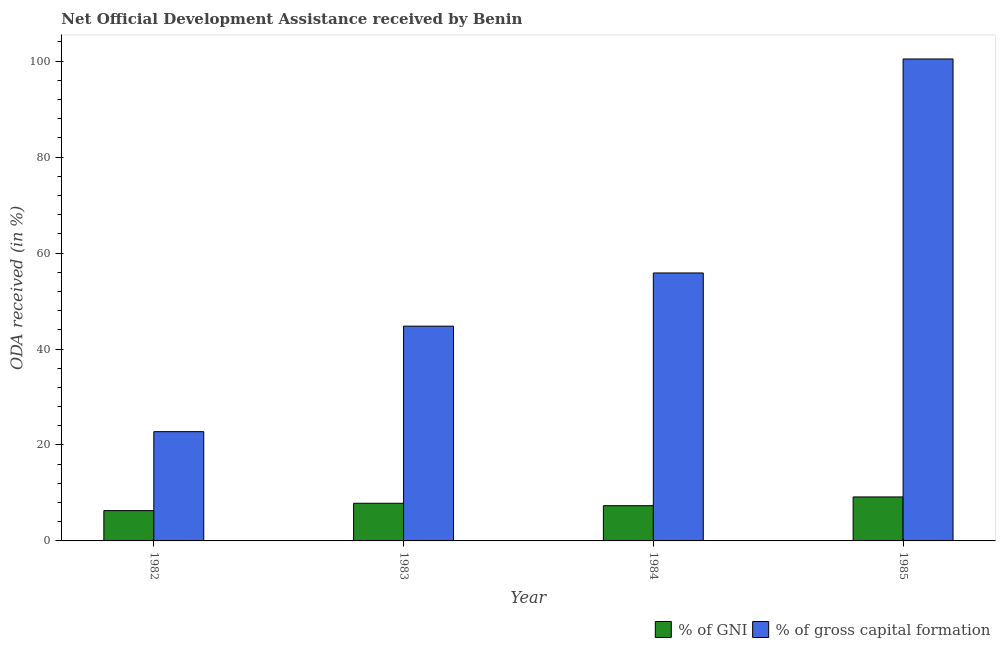Are the number of bars per tick equal to the number of legend labels?
Provide a succinct answer. Yes. Are the number of bars on each tick of the X-axis equal?
Keep it short and to the point. Yes. How many bars are there on the 3rd tick from the left?
Your response must be concise. 2. How many bars are there on the 1st tick from the right?
Give a very brief answer. 2. What is the label of the 4th group of bars from the left?
Provide a short and direct response. 1985. What is the oda received as percentage of gross capital formation in 1984?
Keep it short and to the point. 55.85. Across all years, what is the maximum oda received as percentage of gni?
Your answer should be very brief. 9.17. Across all years, what is the minimum oda received as percentage of gross capital formation?
Provide a short and direct response. 22.77. In which year was the oda received as percentage of gross capital formation maximum?
Keep it short and to the point. 1985. In which year was the oda received as percentage of gross capital formation minimum?
Your answer should be compact. 1982. What is the total oda received as percentage of gross capital formation in the graph?
Provide a short and direct response. 223.84. What is the difference between the oda received as percentage of gross capital formation in 1983 and that in 1985?
Offer a terse response. -55.69. What is the difference between the oda received as percentage of gross capital formation in 1985 and the oda received as percentage of gni in 1983?
Your response must be concise. 55.69. What is the average oda received as percentage of gross capital formation per year?
Offer a very short reply. 55.96. In how many years, is the oda received as percentage of gni greater than 88 %?
Give a very brief answer. 0. What is the ratio of the oda received as percentage of gni in 1982 to that in 1985?
Offer a very short reply. 0.69. Is the oda received as percentage of gni in 1983 less than that in 1984?
Provide a short and direct response. No. Is the difference between the oda received as percentage of gni in 1983 and 1985 greater than the difference between the oda received as percentage of gross capital formation in 1983 and 1985?
Your answer should be very brief. No. What is the difference between the highest and the second highest oda received as percentage of gross capital formation?
Make the answer very short. 44.6. What is the difference between the highest and the lowest oda received as percentage of gni?
Ensure brevity in your answer.  2.85. What does the 1st bar from the left in 1985 represents?
Give a very brief answer. % of GNI. What does the 2nd bar from the right in 1983 represents?
Offer a very short reply. % of GNI. Are all the bars in the graph horizontal?
Ensure brevity in your answer.  No. What is the difference between two consecutive major ticks on the Y-axis?
Your answer should be compact. 20. Are the values on the major ticks of Y-axis written in scientific E-notation?
Provide a succinct answer. No. Does the graph contain any zero values?
Provide a short and direct response. No. Where does the legend appear in the graph?
Offer a very short reply. Bottom right. How many legend labels are there?
Offer a terse response. 2. How are the legend labels stacked?
Make the answer very short. Horizontal. What is the title of the graph?
Your answer should be compact. Net Official Development Assistance received by Benin. What is the label or title of the Y-axis?
Your response must be concise. ODA received (in %). What is the ODA received (in %) in % of GNI in 1982?
Give a very brief answer. 6.32. What is the ODA received (in %) in % of gross capital formation in 1982?
Offer a terse response. 22.77. What is the ODA received (in %) in % of GNI in 1983?
Provide a short and direct response. 7.85. What is the ODA received (in %) in % of gross capital formation in 1983?
Your answer should be compact. 44.76. What is the ODA received (in %) in % of GNI in 1984?
Offer a terse response. 7.34. What is the ODA received (in %) in % of gross capital formation in 1984?
Keep it short and to the point. 55.85. What is the ODA received (in %) of % of GNI in 1985?
Provide a succinct answer. 9.17. What is the ODA received (in %) of % of gross capital formation in 1985?
Your answer should be compact. 100.45. Across all years, what is the maximum ODA received (in %) of % of GNI?
Your response must be concise. 9.17. Across all years, what is the maximum ODA received (in %) in % of gross capital formation?
Offer a very short reply. 100.45. Across all years, what is the minimum ODA received (in %) of % of GNI?
Your response must be concise. 6.32. Across all years, what is the minimum ODA received (in %) in % of gross capital formation?
Provide a short and direct response. 22.77. What is the total ODA received (in %) of % of GNI in the graph?
Offer a very short reply. 30.68. What is the total ODA received (in %) in % of gross capital formation in the graph?
Make the answer very short. 223.84. What is the difference between the ODA received (in %) in % of GNI in 1982 and that in 1983?
Your response must be concise. -1.53. What is the difference between the ODA received (in %) in % of gross capital formation in 1982 and that in 1983?
Keep it short and to the point. -21.99. What is the difference between the ODA received (in %) of % of GNI in 1982 and that in 1984?
Your answer should be compact. -1.03. What is the difference between the ODA received (in %) in % of gross capital formation in 1982 and that in 1984?
Your response must be concise. -33.08. What is the difference between the ODA received (in %) of % of GNI in 1982 and that in 1985?
Keep it short and to the point. -2.85. What is the difference between the ODA received (in %) of % of gross capital formation in 1982 and that in 1985?
Make the answer very short. -77.68. What is the difference between the ODA received (in %) in % of GNI in 1983 and that in 1984?
Offer a very short reply. 0.5. What is the difference between the ODA received (in %) of % of gross capital formation in 1983 and that in 1984?
Keep it short and to the point. -11.09. What is the difference between the ODA received (in %) in % of GNI in 1983 and that in 1985?
Offer a terse response. -1.32. What is the difference between the ODA received (in %) in % of gross capital formation in 1983 and that in 1985?
Provide a succinct answer. -55.69. What is the difference between the ODA received (in %) of % of GNI in 1984 and that in 1985?
Your answer should be compact. -1.82. What is the difference between the ODA received (in %) in % of gross capital formation in 1984 and that in 1985?
Your answer should be very brief. -44.6. What is the difference between the ODA received (in %) in % of GNI in 1982 and the ODA received (in %) in % of gross capital formation in 1983?
Offer a very short reply. -38.45. What is the difference between the ODA received (in %) in % of GNI in 1982 and the ODA received (in %) in % of gross capital formation in 1984?
Offer a very short reply. -49.54. What is the difference between the ODA received (in %) of % of GNI in 1982 and the ODA received (in %) of % of gross capital formation in 1985?
Provide a succinct answer. -94.14. What is the difference between the ODA received (in %) in % of GNI in 1983 and the ODA received (in %) in % of gross capital formation in 1984?
Provide a short and direct response. -48. What is the difference between the ODA received (in %) of % of GNI in 1983 and the ODA received (in %) of % of gross capital formation in 1985?
Your response must be concise. -92.6. What is the difference between the ODA received (in %) in % of GNI in 1984 and the ODA received (in %) in % of gross capital formation in 1985?
Provide a succinct answer. -93.11. What is the average ODA received (in %) in % of GNI per year?
Offer a very short reply. 7.67. What is the average ODA received (in %) in % of gross capital formation per year?
Offer a terse response. 55.96. In the year 1982, what is the difference between the ODA received (in %) in % of GNI and ODA received (in %) in % of gross capital formation?
Provide a short and direct response. -16.46. In the year 1983, what is the difference between the ODA received (in %) in % of GNI and ODA received (in %) in % of gross capital formation?
Your answer should be very brief. -36.91. In the year 1984, what is the difference between the ODA received (in %) of % of GNI and ODA received (in %) of % of gross capital formation?
Offer a terse response. -48.51. In the year 1985, what is the difference between the ODA received (in %) of % of GNI and ODA received (in %) of % of gross capital formation?
Offer a terse response. -91.29. What is the ratio of the ODA received (in %) of % of GNI in 1982 to that in 1983?
Keep it short and to the point. 0.8. What is the ratio of the ODA received (in %) of % of gross capital formation in 1982 to that in 1983?
Keep it short and to the point. 0.51. What is the ratio of the ODA received (in %) in % of GNI in 1982 to that in 1984?
Your response must be concise. 0.86. What is the ratio of the ODA received (in %) of % of gross capital formation in 1982 to that in 1984?
Your answer should be very brief. 0.41. What is the ratio of the ODA received (in %) of % of GNI in 1982 to that in 1985?
Your response must be concise. 0.69. What is the ratio of the ODA received (in %) of % of gross capital formation in 1982 to that in 1985?
Ensure brevity in your answer.  0.23. What is the ratio of the ODA received (in %) of % of GNI in 1983 to that in 1984?
Give a very brief answer. 1.07. What is the ratio of the ODA received (in %) in % of gross capital formation in 1983 to that in 1984?
Provide a succinct answer. 0.8. What is the ratio of the ODA received (in %) in % of GNI in 1983 to that in 1985?
Keep it short and to the point. 0.86. What is the ratio of the ODA received (in %) in % of gross capital formation in 1983 to that in 1985?
Keep it short and to the point. 0.45. What is the ratio of the ODA received (in %) in % of GNI in 1984 to that in 1985?
Give a very brief answer. 0.8. What is the ratio of the ODA received (in %) of % of gross capital formation in 1984 to that in 1985?
Offer a terse response. 0.56. What is the difference between the highest and the second highest ODA received (in %) in % of GNI?
Keep it short and to the point. 1.32. What is the difference between the highest and the second highest ODA received (in %) in % of gross capital formation?
Your answer should be compact. 44.6. What is the difference between the highest and the lowest ODA received (in %) in % of GNI?
Provide a succinct answer. 2.85. What is the difference between the highest and the lowest ODA received (in %) of % of gross capital formation?
Give a very brief answer. 77.68. 